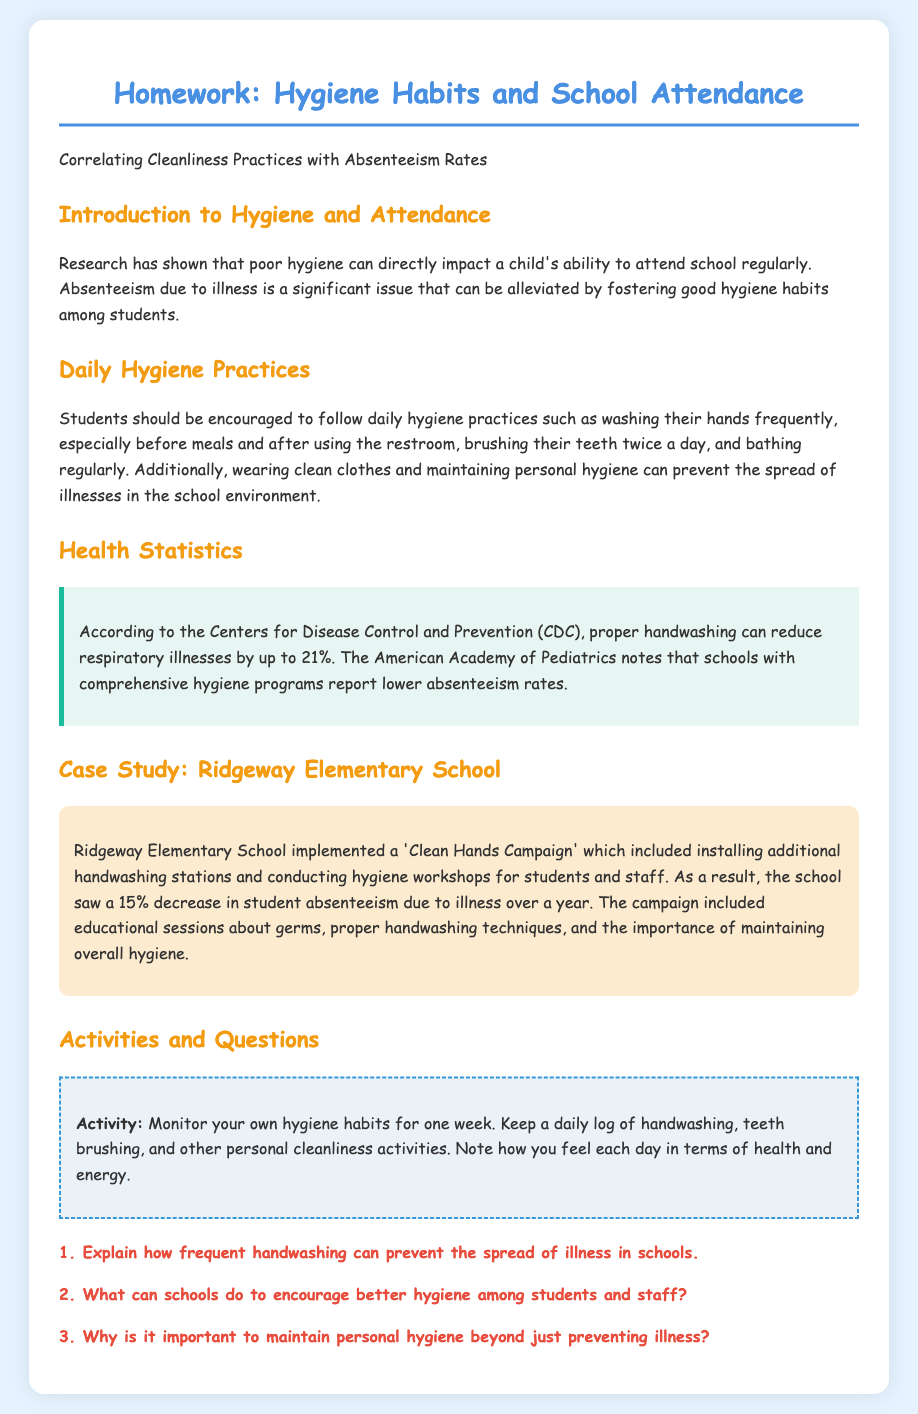What is the title of the homework? The title of the homework is the main heading featured at the top of the document.
Answer: Homework: Hygiene Habits and School Attendance What percentage decrease in absenteeism was noted at Ridgeway Elementary School? This statistic is mentioned in the case study, highlighting the effect of the Clean Hands Campaign on absenteeism.
Answer: 15% Which organization reports that proper handwashing can reduce respiratory illnesses by up to 21%? This information is found in the Health Statistics section of the document.
Answer: Centers for Disease Control and Prevention (CDC) What daily hygiene practices are recommended in the document? This question requires recalling the specific practices outlined in the Daily Hygiene Practices section.
Answer: Washing hands, brushing teeth, bathing regularly What is the purpose of the 'Clean Hands Campaign'? This question addresses the aim behind the implemented program at Ridgeway Elementary School, as described in the case study.
Answer: To decrease absenteeism due to illness Why is it important to maintain personal hygiene beyond just preventing illness? This question encourages students to think broadly about personal hygiene's impact, as implied in the document.
Answer: Prevents the spread of illnesses 